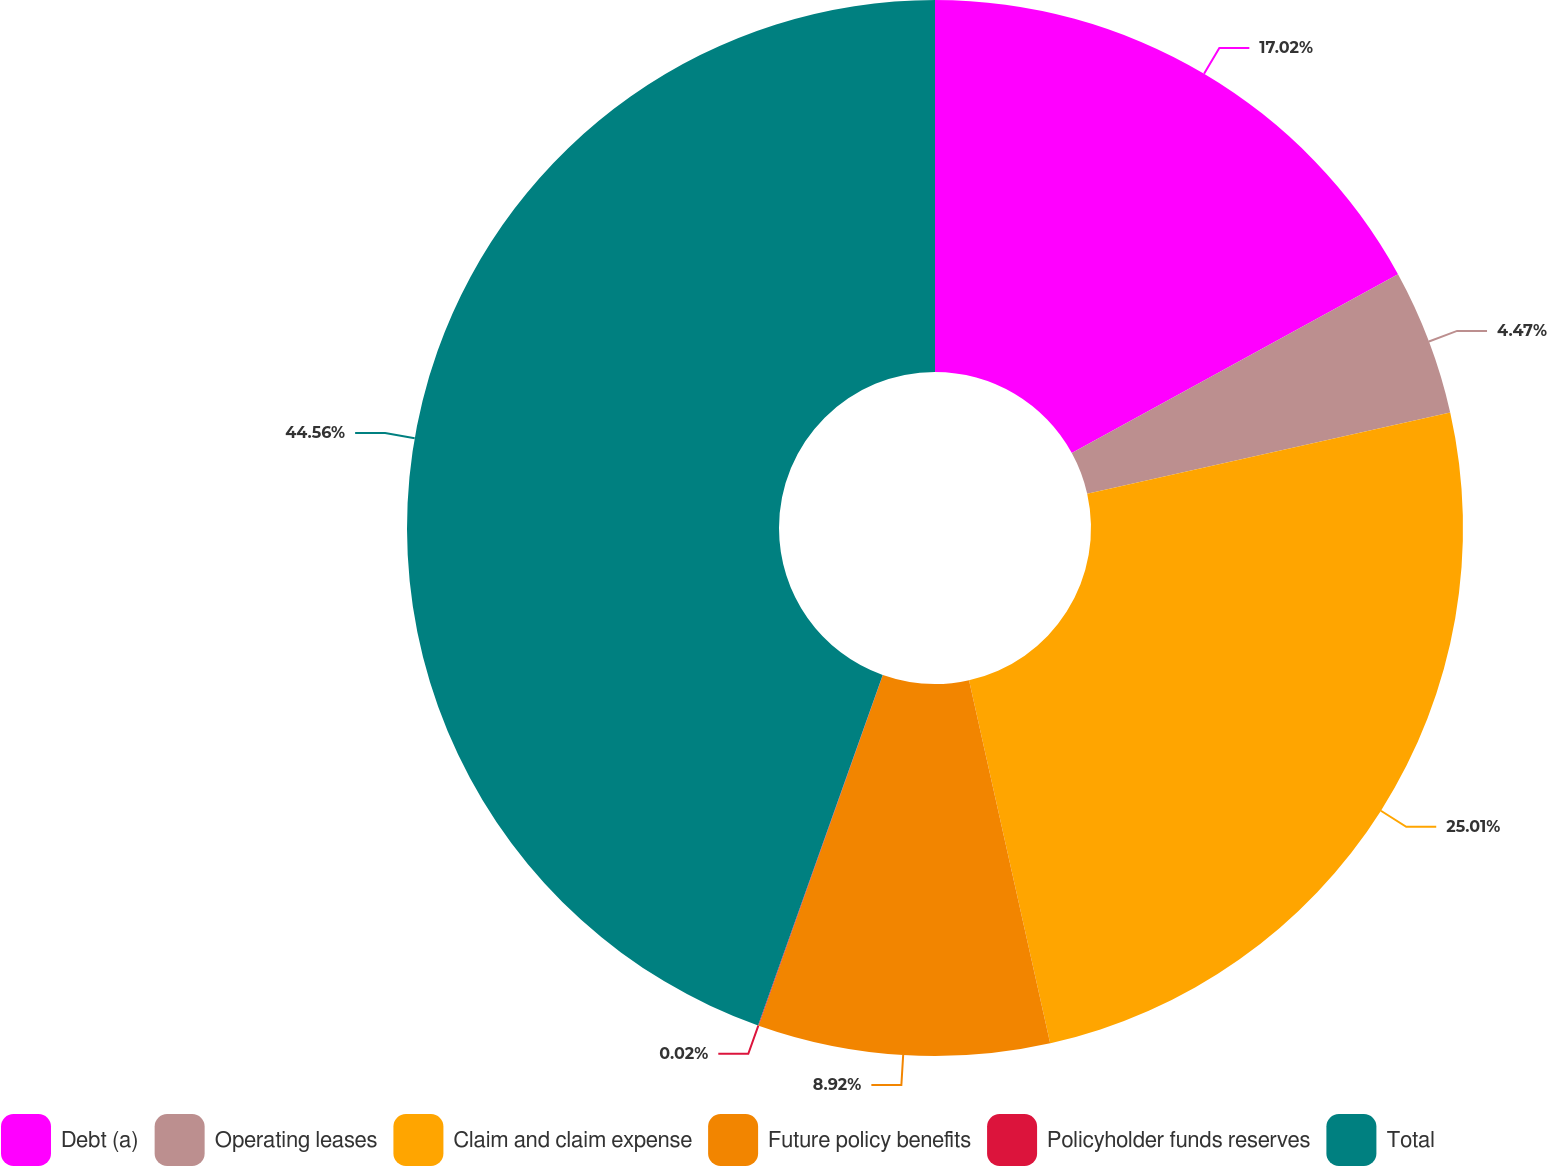Convert chart to OTSL. <chart><loc_0><loc_0><loc_500><loc_500><pie_chart><fcel>Debt (a)<fcel>Operating leases<fcel>Claim and claim expense<fcel>Future policy benefits<fcel>Policyholder funds reserves<fcel>Total<nl><fcel>17.02%<fcel>4.47%<fcel>25.01%<fcel>8.92%<fcel>0.02%<fcel>44.56%<nl></chart> 